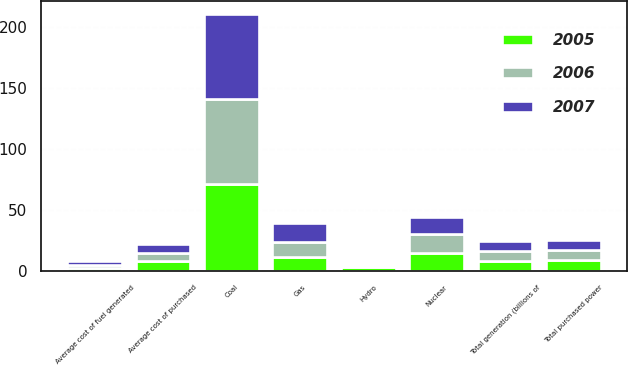Convert chart to OTSL. <chart><loc_0><loc_0><loc_500><loc_500><stacked_bar_chart><ecel><fcel>Total generation (billions of<fcel>Total purchased power<fcel>Coal<fcel>Nuclear<fcel>Gas<fcel>Hydro<fcel>Average cost of fuel generated<fcel>Average cost of purchased<nl><fcel>2007<fcel>8.04<fcel>8<fcel>70<fcel>14<fcel>15<fcel>1<fcel>2.89<fcel>7.2<nl><fcel>2006<fcel>8.04<fcel>8<fcel>70<fcel>15<fcel>13<fcel>2<fcel>2.64<fcel>6.82<nl><fcel>2005<fcel>8.04<fcel>9<fcel>71<fcel>15<fcel>11<fcel>3<fcel>2.39<fcel>8.04<nl></chart> 